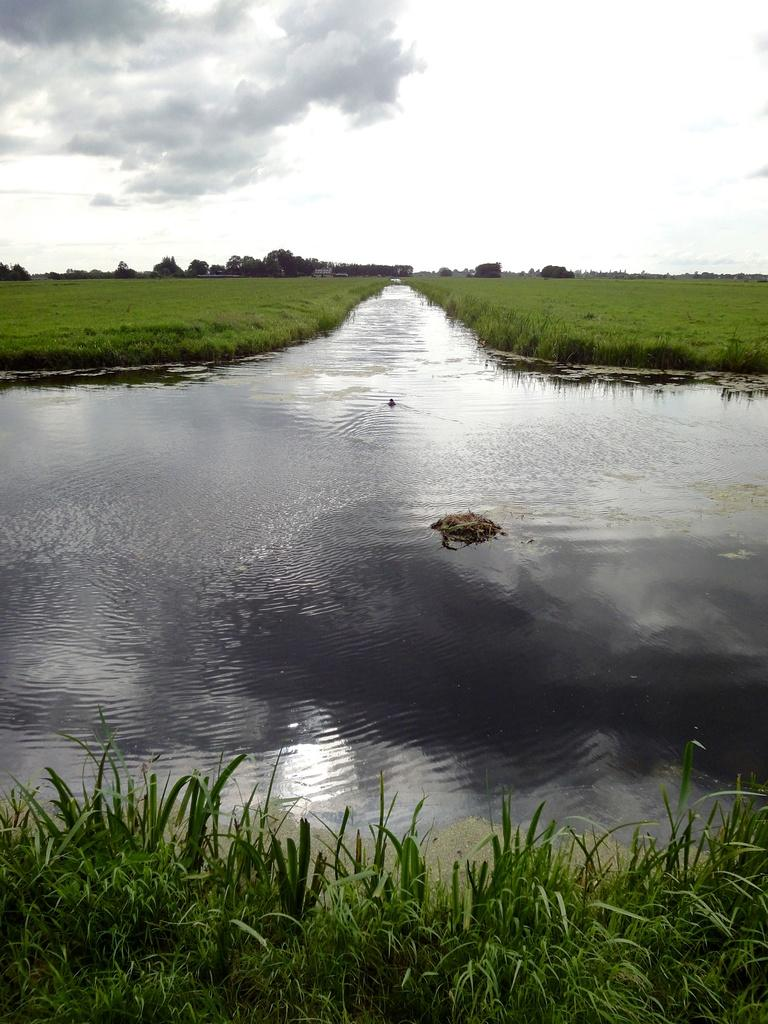What type of water feature can be seen in the image? There is a water channel in the image. What type of land is being used in the image? Agricultural fields are present in the image. What type of vegetation is in the image? There are trees in the image. What is visible in the sky in the image? The sky is visible in the image, and clouds are present. Can you see any bombs or wounds in the image? No, there are no bombs or wounds present in the image. Is there a school visible in the image? No, there is no school present in the image. 